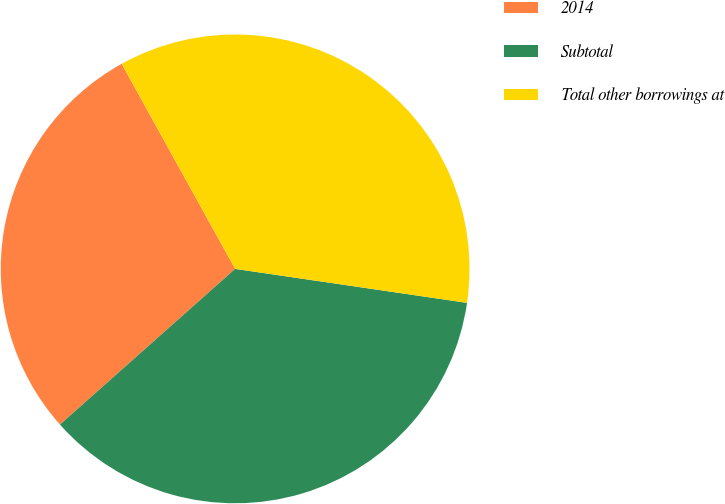<chart> <loc_0><loc_0><loc_500><loc_500><pie_chart><fcel>2014<fcel>Subtotal<fcel>Total other borrowings at<nl><fcel>28.52%<fcel>36.12%<fcel>35.36%<nl></chart> 